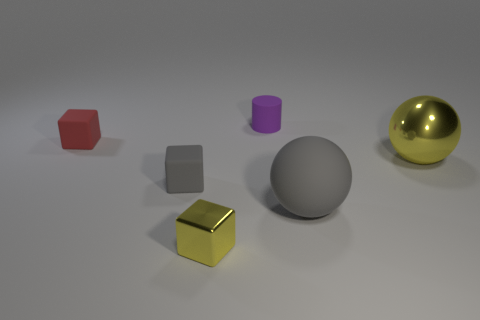Add 2 rubber blocks. How many objects exist? 8 Subtract all balls. How many objects are left? 4 Add 4 purple objects. How many purple objects exist? 5 Subtract 0 green spheres. How many objects are left? 6 Subtract all big blue matte cylinders. Subtract all big rubber balls. How many objects are left? 5 Add 4 tiny red objects. How many tiny red objects are left? 5 